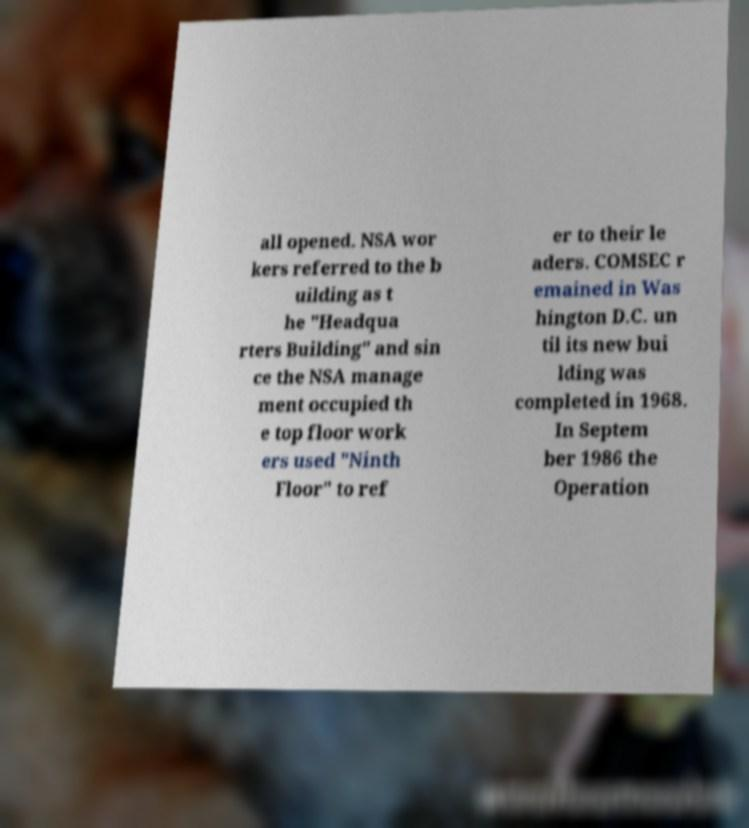For documentation purposes, I need the text within this image transcribed. Could you provide that? all opened. NSA wor kers referred to the b uilding as t he "Headqua rters Building" and sin ce the NSA manage ment occupied th e top floor work ers used "Ninth Floor" to ref er to their le aders. COMSEC r emained in Was hington D.C. un til its new bui lding was completed in 1968. In Septem ber 1986 the Operation 